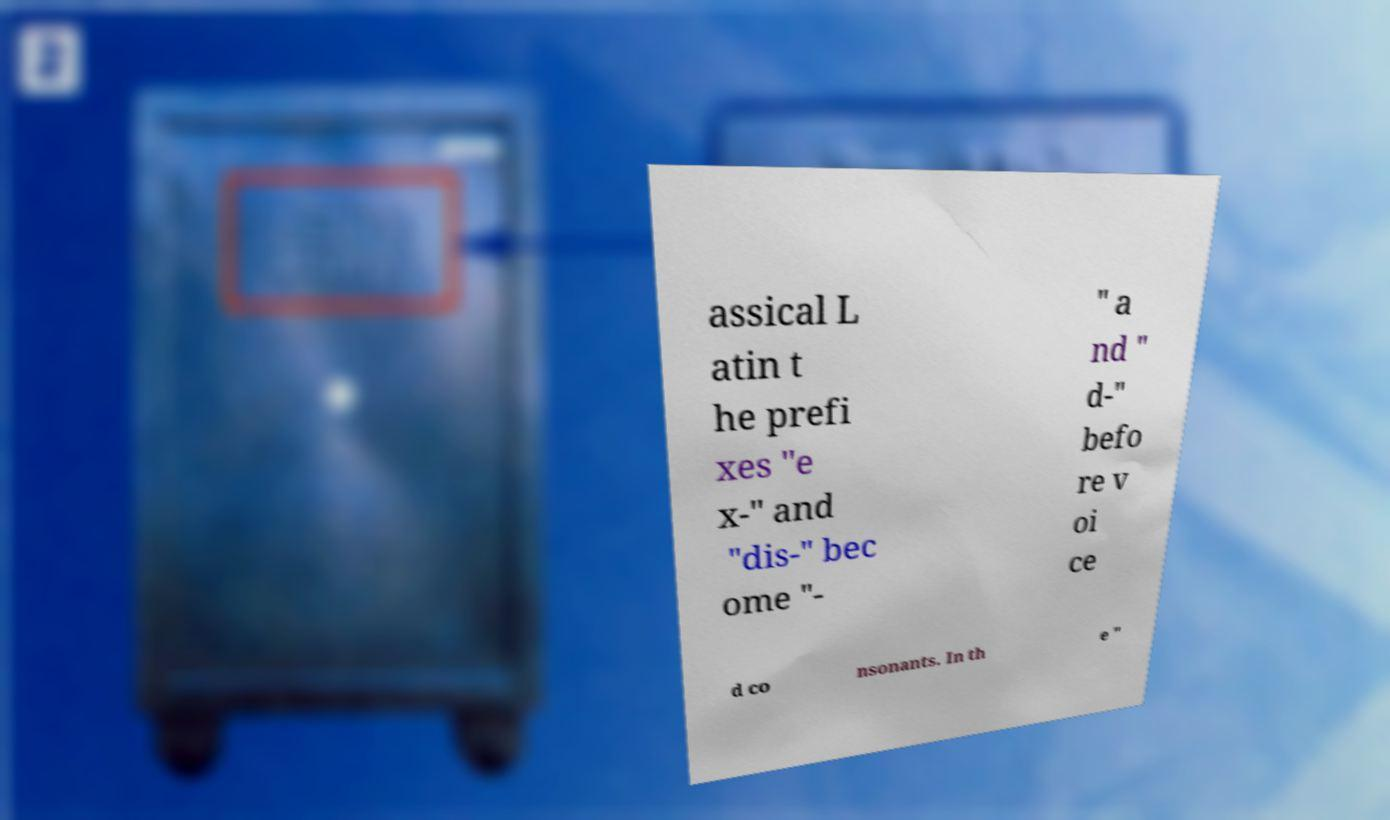There's text embedded in this image that I need extracted. Can you transcribe it verbatim? assical L atin t he prefi xes "e x-" and "dis-" bec ome "- " a nd " d-" befo re v oi ce d co nsonants. In th e " 